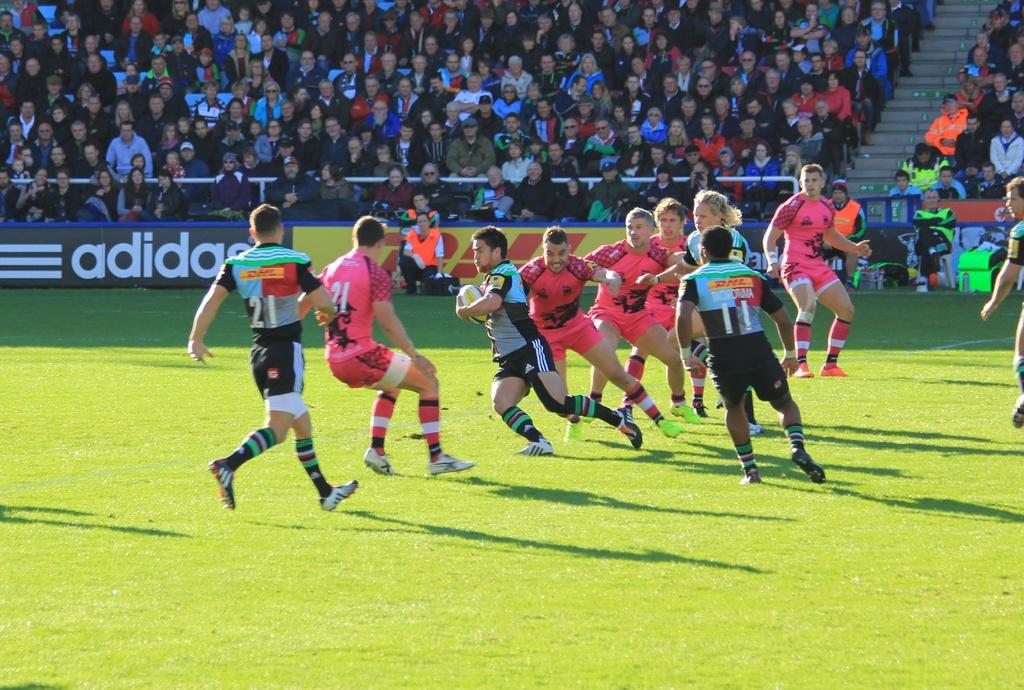Who is sponsoring this stadiium?
Provide a short and direct response. Adidas. What is the number on the green shirt on the right?
Provide a succinct answer. 11. 